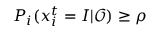<formula> <loc_0><loc_0><loc_500><loc_500>P _ { i } ( x _ { i } ^ { t } = I | \mathcal { O } ) \geq \rho</formula> 